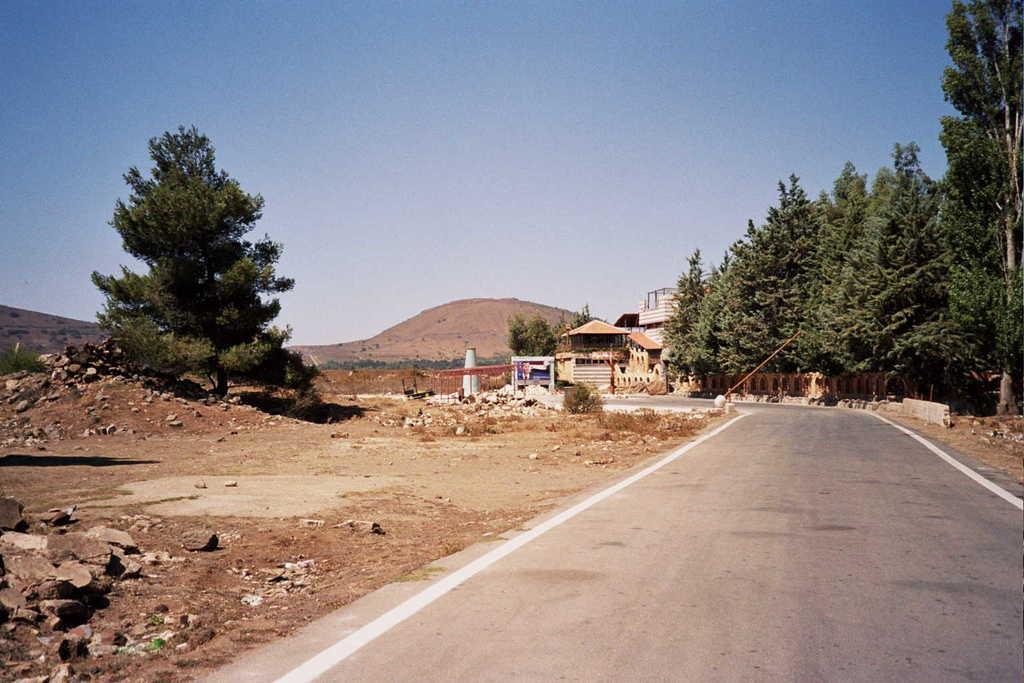Can you describe this image briefly? This picture is taken from outside of the city. In this image, on the right side, we can see some trees, stones, wood grill. On the left side, we can also see some trees, stones, rocks, plants. In the middle of the image, we can see a pillar, houses, staircase, building. In the background, we can also see some trees, rocks. At the top, we can see a sky, at the bottom, we can see a road and a land with some stones. 